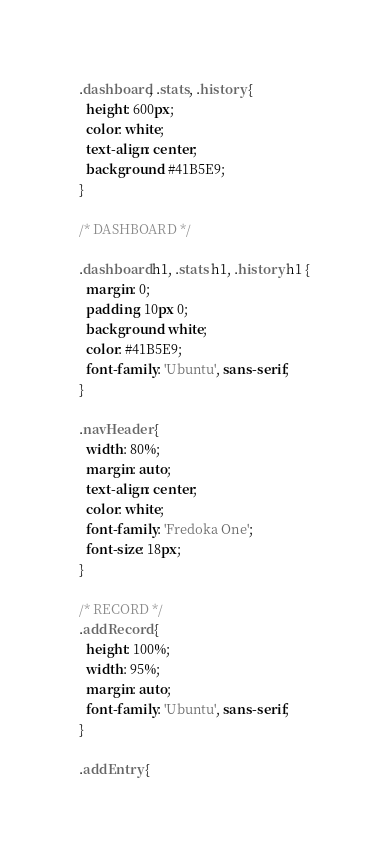Convert code to text. <code><loc_0><loc_0><loc_500><loc_500><_CSS_>.dashboard, .stats, .history {
  height: 600px;
  color: white;
  text-align: center;
  background: #41B5E9;
}

/* DASHBOARD */

.dashboard h1, .stats h1, .history h1 {
  margin: 0;
  padding: 10px 0;
  background: white;
  color: #41B5E9;
  font-family: 'Ubuntu', sans-serif;
}

.navHeader {
  width: 80%;
  margin: auto;
  text-align: center;
  color: white;
  font-family: 'Fredoka One';
  font-size: 18px;
}

/* RECORD */
.addRecord {
  height: 100%;
  width: 95%;
  margin: auto;
  font-family: 'Ubuntu', sans-serif;
}

.addEntry {</code> 